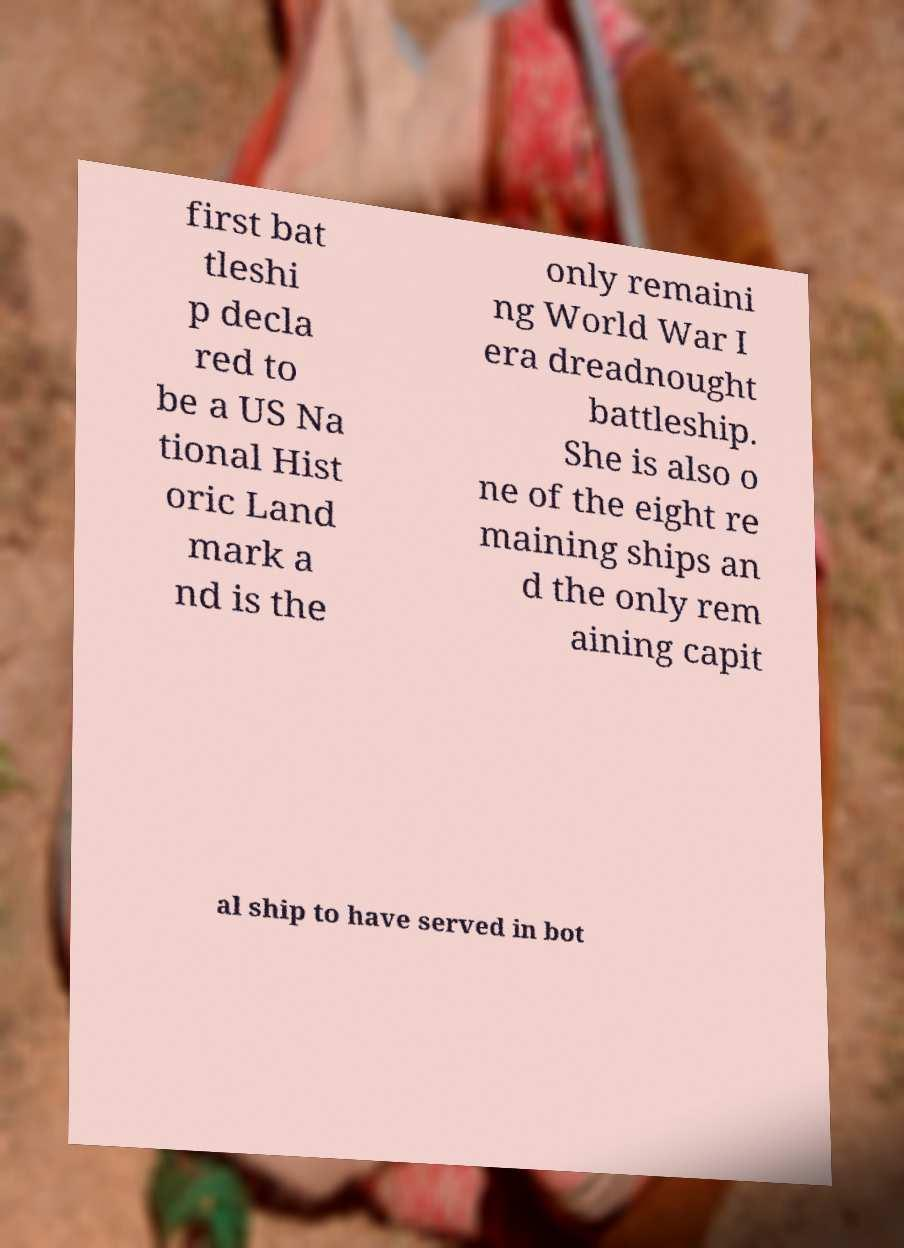Please read and relay the text visible in this image. What does it say? first bat tleshi p decla red to be a US Na tional Hist oric Land mark a nd is the only remaini ng World War I era dreadnought battleship. She is also o ne of the eight re maining ships an d the only rem aining capit al ship to have served in bot 